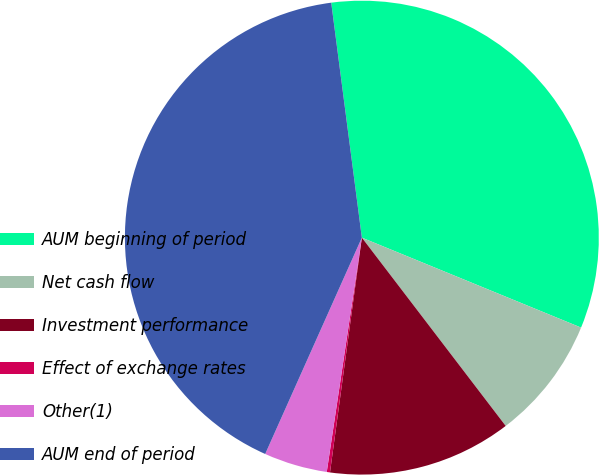Convert chart. <chart><loc_0><loc_0><loc_500><loc_500><pie_chart><fcel>AUM beginning of period<fcel>Net cash flow<fcel>Investment performance<fcel>Effect of exchange rates<fcel>Other(1)<fcel>AUM end of period<nl><fcel>33.26%<fcel>8.42%<fcel>12.53%<fcel>0.22%<fcel>4.32%<fcel>41.25%<nl></chart> 